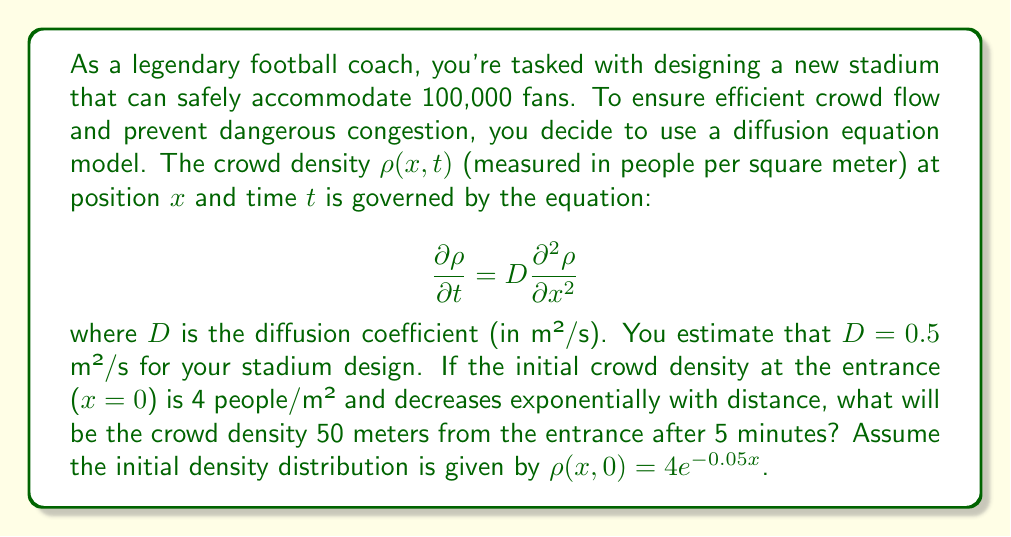Teach me how to tackle this problem. To solve this problem, we need to use the solution to the diffusion equation for an initial exponential distribution. The solution is given by:

$$\rho(x,t) = \frac{4}{\sqrt{1+4Dt/\lambda^2}} \exp\left(-\frac{0.05x}{\sqrt{1+4Dt/\lambda^2}}\right)$$

where $\lambda = 1/0.05 = 20$ (the characteristic length of the initial distribution).

Let's plug in our values:
- $D = 0.5$ m²/s
- $t = 5$ minutes = 300 seconds
- $x = 50$ meters

First, calculate $4Dt/\lambda^2$:

$$\frac{4Dt}{\lambda^2} = \frac{4 \cdot 0.5 \cdot 300}{20^2} = 1.5$$

Now, we can substitute this into our solution:

$$\rho(50,300) = \frac{4}{\sqrt{1+1.5}} \exp\left(-\frac{0.05 \cdot 50}{\sqrt{1+1.5}}\right)$$

$$= \frac{4}{\sqrt{2.5}} \exp\left(-\frac{2.5}{\sqrt{2.5}}\right)$$

$$= 2.53 \cdot \exp(-1.58)$$

$$= 2.53 \cdot 0.206$$

$$= 0.521$$

Therefore, the crowd density 50 meters from the entrance after 5 minutes will be approximately 0.521 people/m².
Answer: 0.521 people/m² 